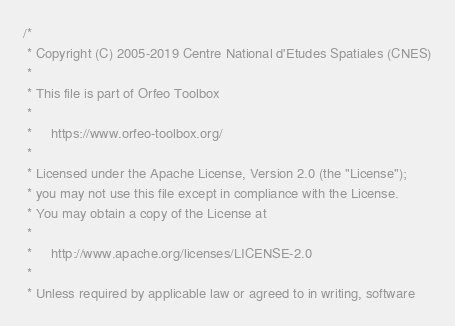Convert code to text. <code><loc_0><loc_0><loc_500><loc_500><_C++_>/*
 * Copyright (C) 2005-2019 Centre National d'Etudes Spatiales (CNES)
 *
 * This file is part of Orfeo Toolbox
 *
 *     https://www.orfeo-toolbox.org/
 *
 * Licensed under the Apache License, Version 2.0 (the "License");
 * you may not use this file except in compliance with the License.
 * You may obtain a copy of the License at
 *
 *     http://www.apache.org/licenses/LICENSE-2.0
 *
 * Unless required by applicable law or agreed to in writing, software</code> 